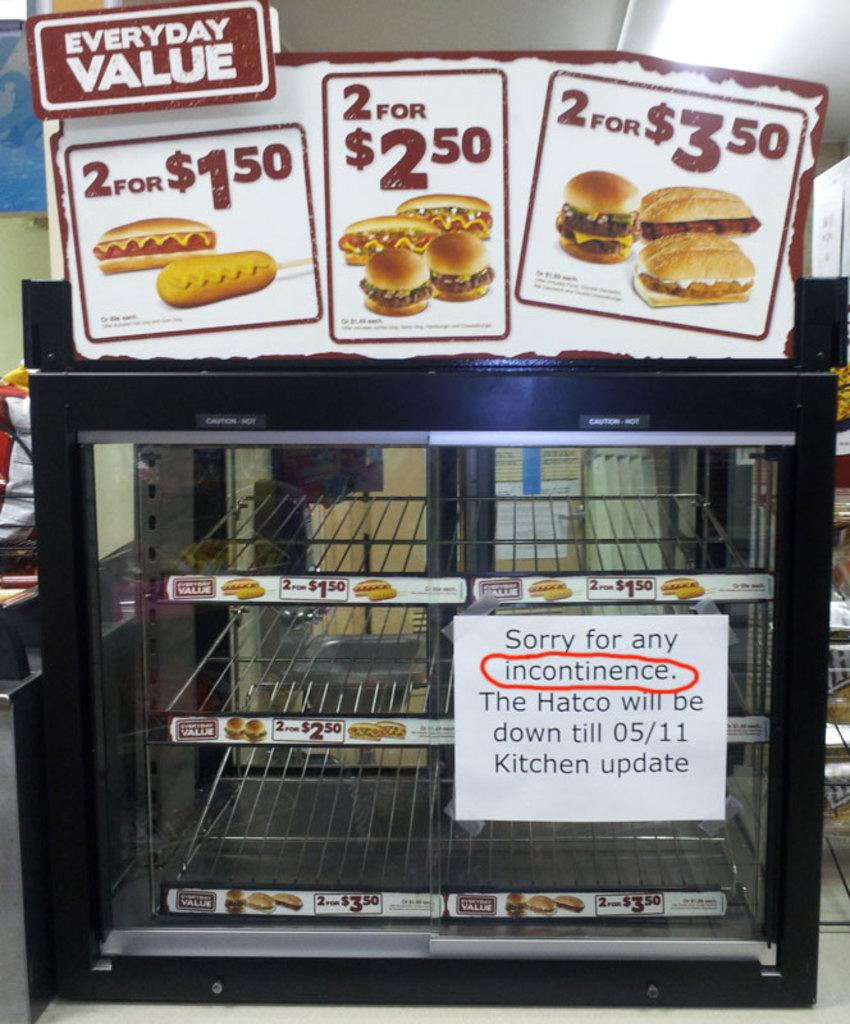<image>
Create a compact narrative representing the image presented. an empty display case with signs advertising everyday value 